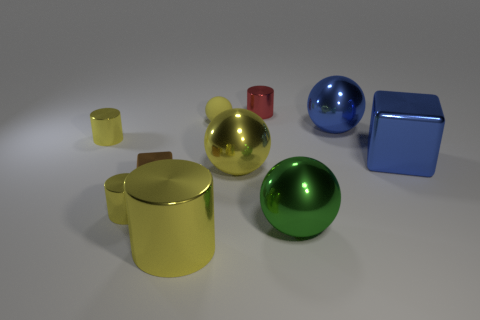Is the tiny red object made of the same material as the tiny yellow thing right of the brown block?
Your response must be concise. No. Is there anything else of the same color as the large metallic cylinder?
Provide a short and direct response. Yes. How many things are large yellow things on the right side of the big metal cylinder or small metal cylinders to the left of the tiny red metallic object?
Keep it short and to the point. 3. There is a small metal thing that is behind the blue block and to the left of the rubber thing; what shape is it?
Make the answer very short. Cylinder. What number of big yellow objects are right of the tiny yellow metal cylinder that is in front of the tiny brown cube?
Your answer should be very brief. 2. Is there anything else that has the same material as the tiny yellow ball?
Your answer should be very brief. No. What number of things are large yellow metallic objects on the left side of the small red metallic cylinder or tiny rubber balls?
Ensure brevity in your answer.  3. How big is the blue thing that is behind the big metallic block?
Keep it short and to the point. Large. What material is the big yellow cylinder?
Provide a succinct answer. Metal. What is the shape of the big yellow object on the left side of the large sphere that is left of the red metallic thing?
Keep it short and to the point. Cylinder. 